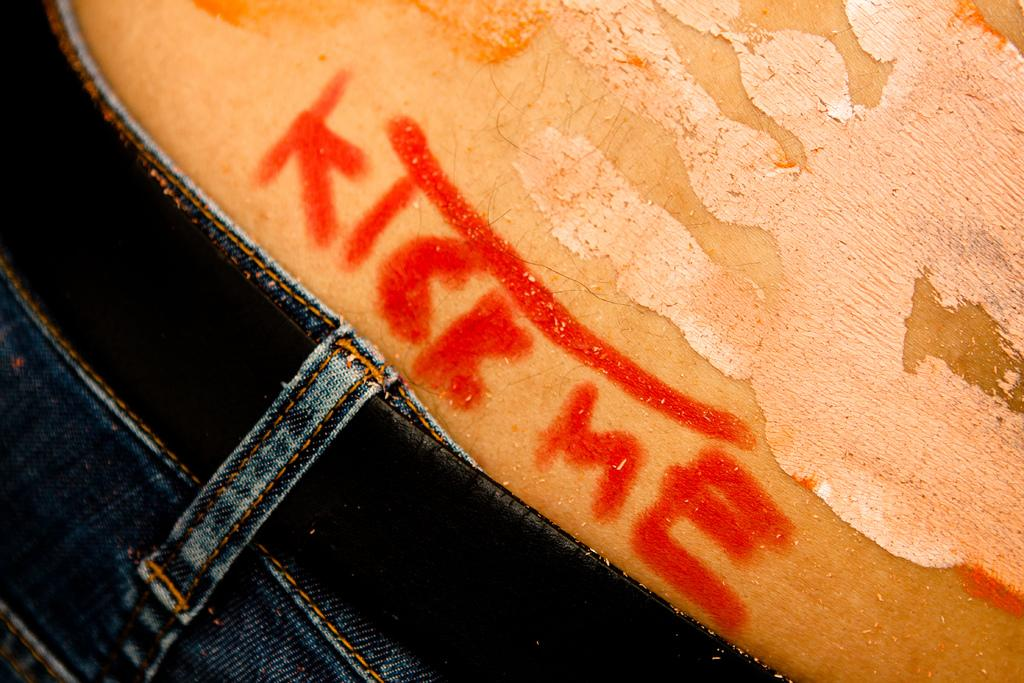What is present in the image? There is a person and text in the image. Can you describe the person in the image? Unfortunately, the provided facts do not give any details about the person's appearance or actions. What can you tell about the time of day when the image was taken? The image was likely taken during the day, as there is no mention of darkness or artificial lighting. What type of substance is being used to clean the cars in the image? There is no mention of cars or cleaning substances in the image, so it is not possible to answer that question. 